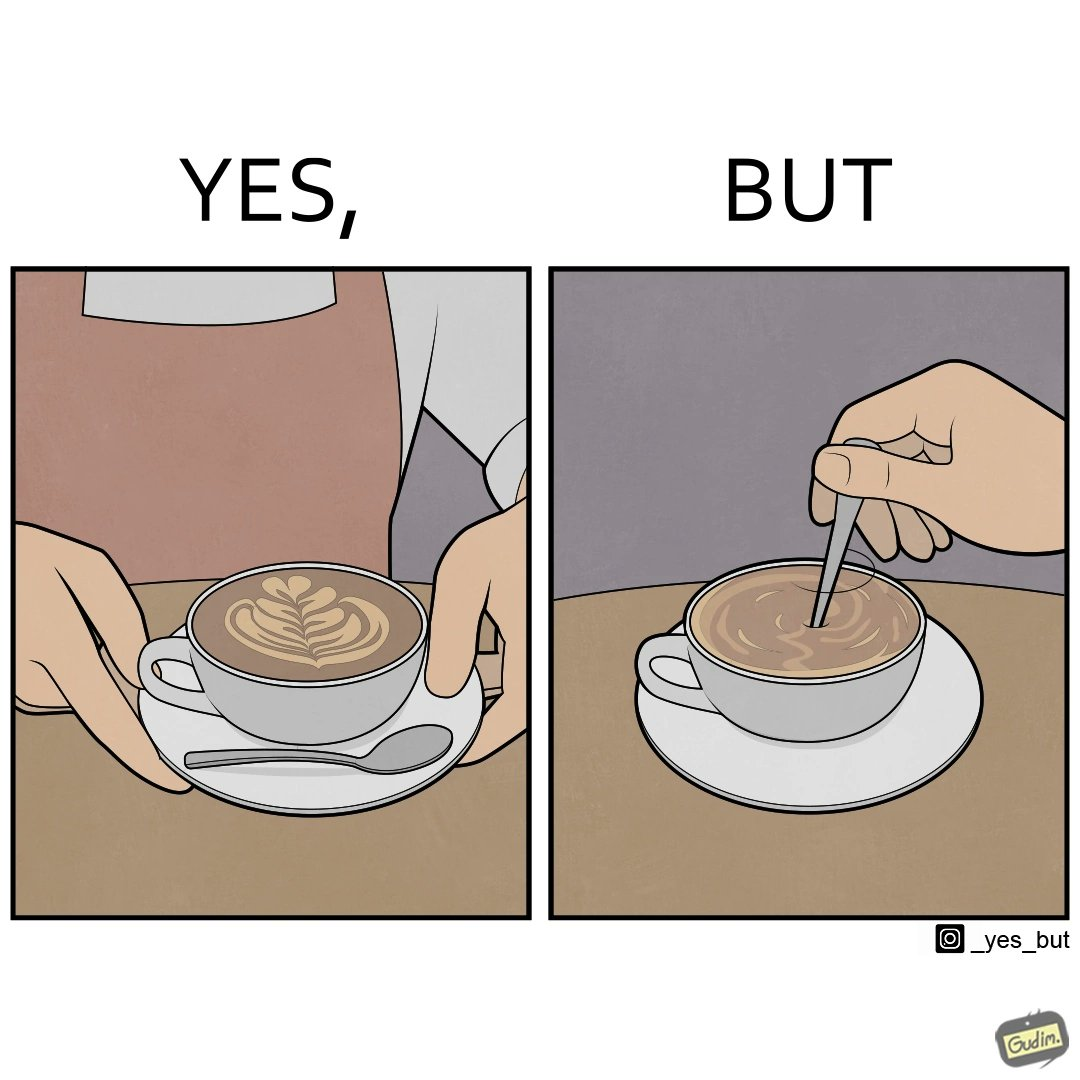Why is this image considered satirical? The image is ironic, because even when the coffee maker create latte art to make coffee look attractive but it is there just for a short time after that it is vanished 